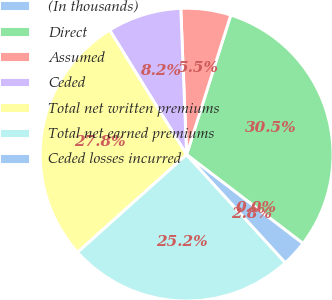Convert chart. <chart><loc_0><loc_0><loc_500><loc_500><pie_chart><fcel>(In thousands)<fcel>Direct<fcel>Assumed<fcel>Ceded<fcel>Total net written premiums<fcel>Total net earned premiums<fcel>Ceded losses incurred<nl><fcel>0.01%<fcel>30.49%<fcel>5.51%<fcel>8.18%<fcel>27.82%<fcel>25.15%<fcel>2.84%<nl></chart> 